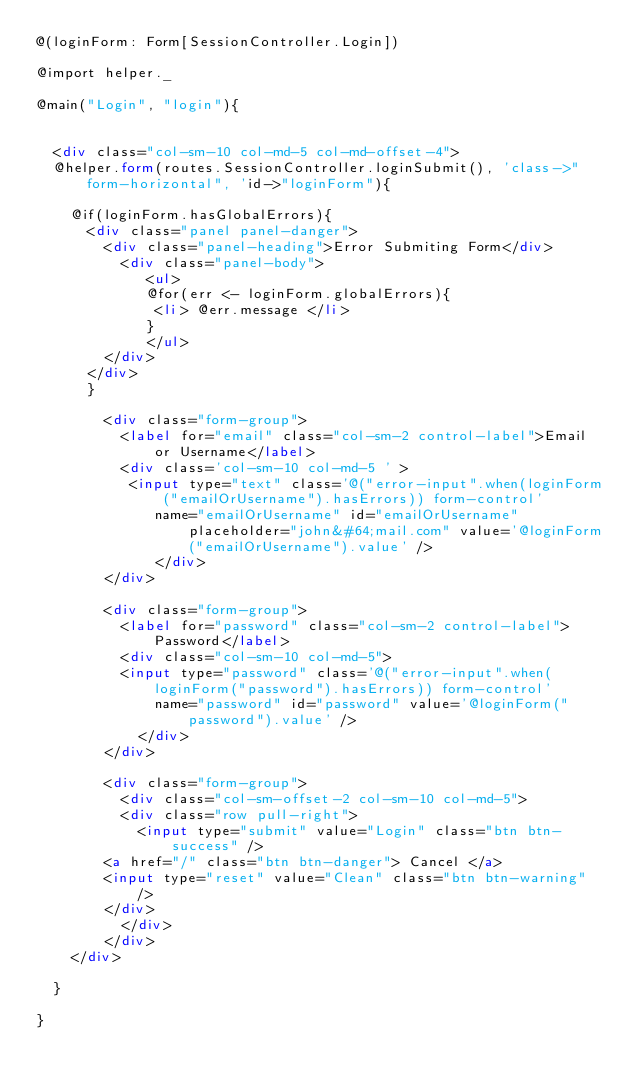Convert code to text. <code><loc_0><loc_0><loc_500><loc_500><_HTML_>@(loginForm: Form[SessionController.Login])

@import helper._

@main("Login", "login"){
	
	
	<div class="col-sm-10 col-md-5 col-md-offset-4">
	@helper.form(routes.SessionController.loginSubmit(), 'class->"form-horizontal", 'id->"loginForm"){
		
		@if(loginForm.hasGlobalErrors){
			<div class="panel panel-danger">
				<div class="panel-heading">Error Submiting Form</div>
		  		<div class="panel-body">
		   			 <ul>
		   			 @for(err <- loginForm.globalErrors){
		  				<li> @err.message </li>
		   			 }
		   			 </ul>
		 		</div>
			</div>
			}
		  
			  <div class="form-group">
			    <label for="email" class="col-sm-2 control-label">Email or Username</label>
			    <div class='col-sm-10 col-md-5 ' >
			     <input type="text" class='@("error-input".when(loginForm("emailOrUsername").hasErrors)) form-control' 
      				name="emailOrUsername" id="emailOrUsername" placeholder="john&#64;mail.com" value='@loginForm("emailOrUsername").value' />	
      		    </div>
			  </div>
			  
			  <div class="form-group">
			    <label for="password" class="col-sm-2 control-label">Password</label>
			    <div class="col-sm-10 col-md-5">
			    <input type="password" class='@("error-input".when(loginForm("password").hasErrors)) form-control'
       				name="password" id="password" value='@loginForm("password").value' />
       			</div>
			  </div>
			
			  <div class="form-group">
			    <div class="col-sm-offset-2 col-sm-10 col-md-5">
			    <div class="row pull-right">
			      <input type="submit" value="Login" class="btn btn-success" />
				<a href="/" class="btn btn-danger"> Cancel </a>
				<input type="reset" value="Clean" class="btn btn-warning" />
				</div>
			    </div>
			  </div>
		</div>

	}

}
</code> 